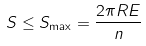<formula> <loc_0><loc_0><loc_500><loc_500>S \leq S _ { \max } = \frac { 2 \pi R E } { n }</formula> 